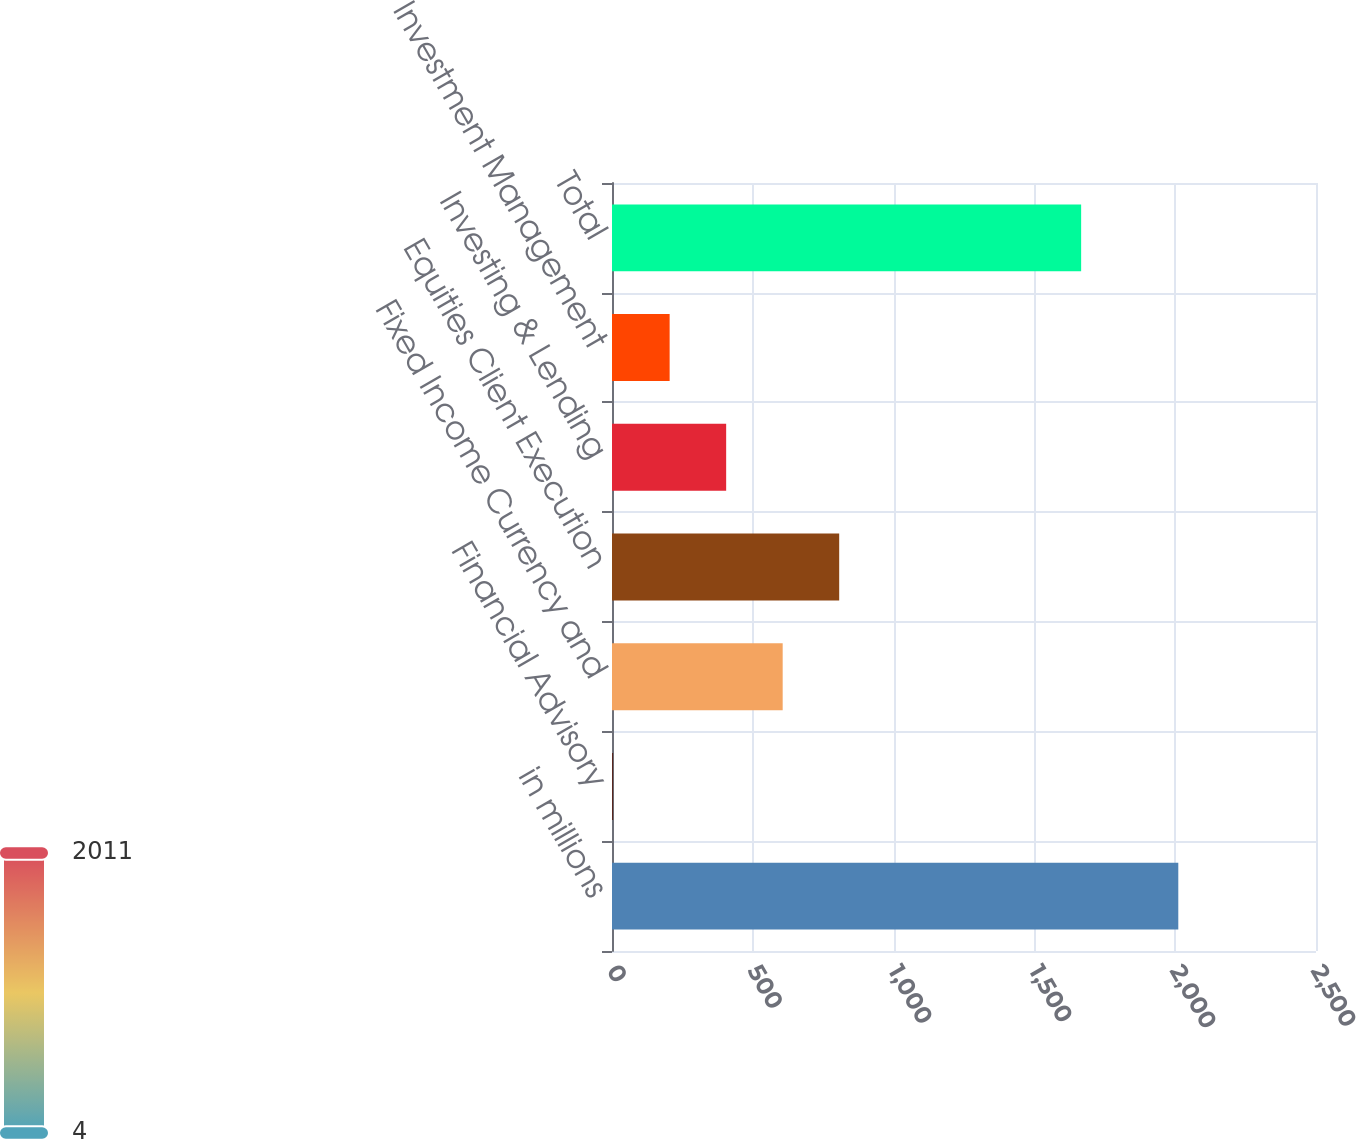Convert chart. <chart><loc_0><loc_0><loc_500><loc_500><bar_chart><fcel>in millions<fcel>Financial Advisory<fcel>Fixed Income Currency and<fcel>Equities Client Execution<fcel>Investing & Lending<fcel>Investment Management<fcel>Total<nl><fcel>2011<fcel>4<fcel>606.1<fcel>806.8<fcel>405.4<fcel>204.7<fcel>1666<nl></chart> 